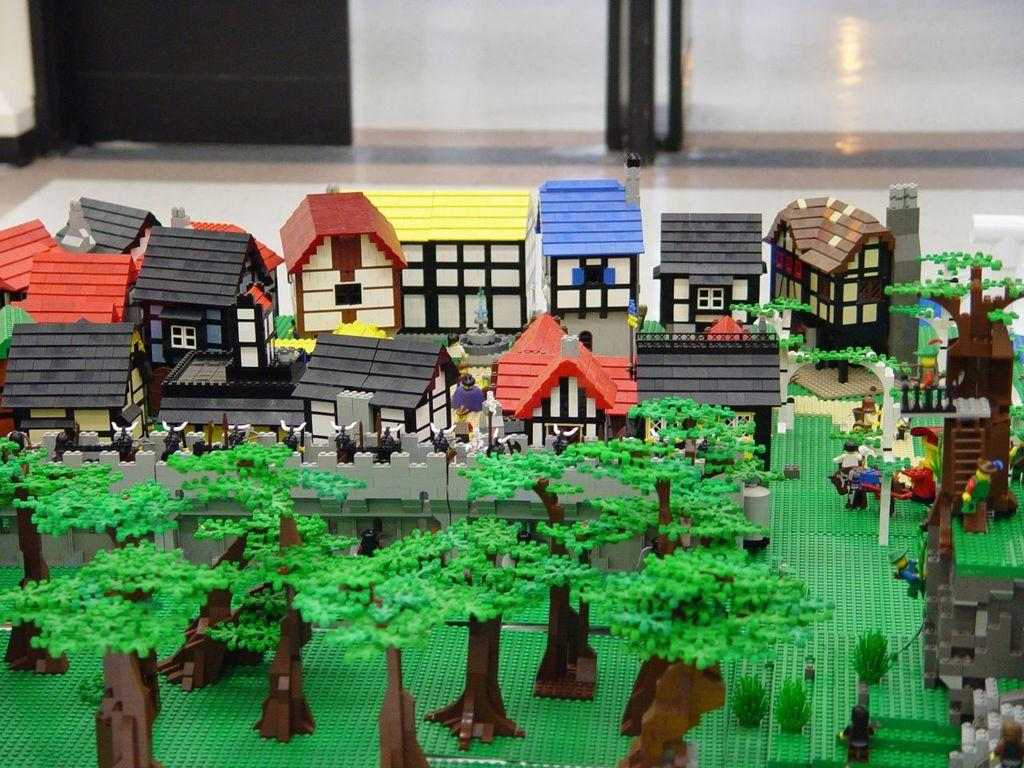What type of toys are present in the image? There are toy houses, toy people, and toy trees in the image. What is the surface on which the toys are placed? The floor is visible in the image. How much paste is needed to fix the toy houses in the image? There is no mention of paste or any need for fixing in the image; the toy houses are already intact. 